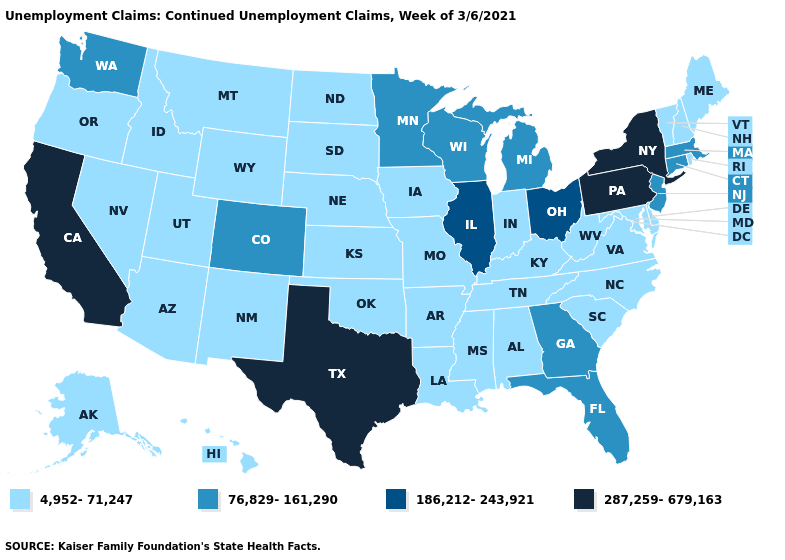What is the value of Missouri?
Write a very short answer. 4,952-71,247. What is the value of Utah?
Short answer required. 4,952-71,247. What is the value of Ohio?
Answer briefly. 186,212-243,921. Name the states that have a value in the range 4,952-71,247?
Give a very brief answer. Alabama, Alaska, Arizona, Arkansas, Delaware, Hawaii, Idaho, Indiana, Iowa, Kansas, Kentucky, Louisiana, Maine, Maryland, Mississippi, Missouri, Montana, Nebraska, Nevada, New Hampshire, New Mexico, North Carolina, North Dakota, Oklahoma, Oregon, Rhode Island, South Carolina, South Dakota, Tennessee, Utah, Vermont, Virginia, West Virginia, Wyoming. Does Ohio have the lowest value in the MidWest?
Keep it brief. No. Name the states that have a value in the range 287,259-679,163?
Write a very short answer. California, New York, Pennsylvania, Texas. Name the states that have a value in the range 76,829-161,290?
Answer briefly. Colorado, Connecticut, Florida, Georgia, Massachusetts, Michigan, Minnesota, New Jersey, Washington, Wisconsin. Is the legend a continuous bar?
Write a very short answer. No. Name the states that have a value in the range 76,829-161,290?
Quick response, please. Colorado, Connecticut, Florida, Georgia, Massachusetts, Michigan, Minnesota, New Jersey, Washington, Wisconsin. Which states have the lowest value in the West?
Concise answer only. Alaska, Arizona, Hawaii, Idaho, Montana, Nevada, New Mexico, Oregon, Utah, Wyoming. Does the first symbol in the legend represent the smallest category?
Give a very brief answer. Yes. Does Ohio have the lowest value in the USA?
Quick response, please. No. What is the value of Indiana?
Give a very brief answer. 4,952-71,247. Among the states that border Tennessee , does Georgia have the lowest value?
Concise answer only. No. What is the highest value in the South ?
Keep it brief. 287,259-679,163. 